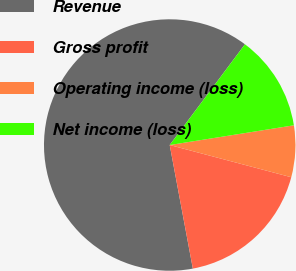<chart> <loc_0><loc_0><loc_500><loc_500><pie_chart><fcel>Revenue<fcel>Gross profit<fcel>Operating income (loss)<fcel>Net income (loss)<nl><fcel>63.15%<fcel>17.93%<fcel>6.63%<fcel>12.28%<nl></chart> 